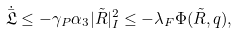Convert formula to latex. <formula><loc_0><loc_0><loc_500><loc_500>\dot { \bar { \mathfrak { L } } } \leq - \gamma _ { P } \alpha _ { 3 } | \tilde { R } | _ { I } ^ { 2 } \leq - \lambda _ { F } \Phi ( \tilde { R } , q ) ,</formula> 